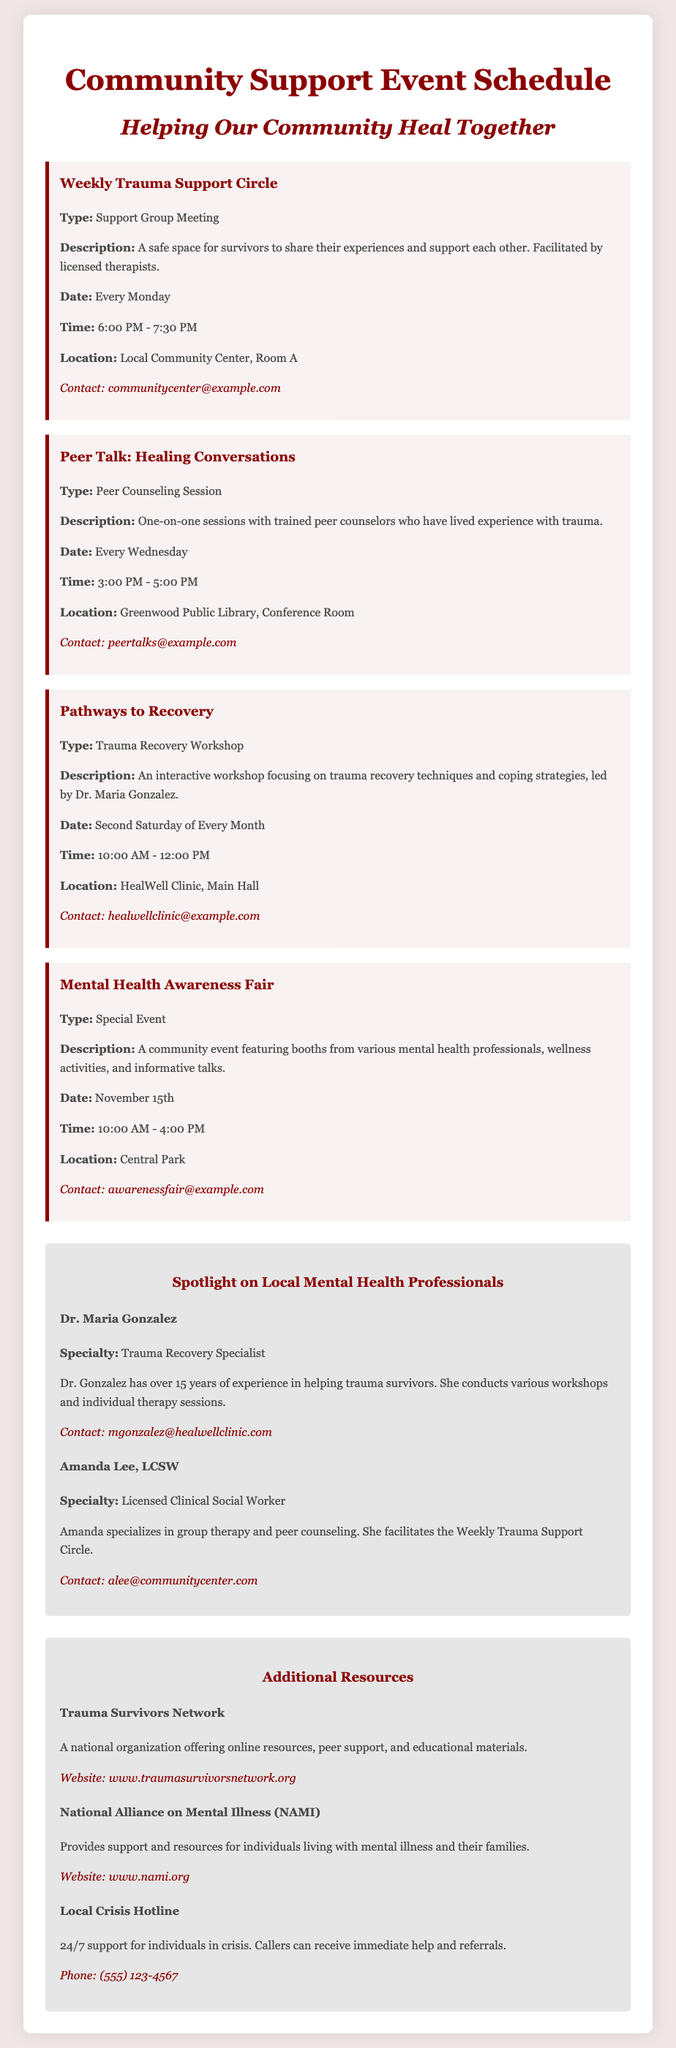What is the location of the Weekly Trauma Support Circle? The location for the Weekly Trauma Support Circle is specified as the Local Community Center, Room A.
Answer: Local Community Center, Room A What day and time does the Pathways to Recovery workshop occur? The Pathways to Recovery workshop takes place on the second Saturday of every month from 10:00 AM to 12:00 PM.
Answer: Second Saturday of Every Month, 10:00 AM - 12:00 PM Who facilitates the Peer Talk: Healing Conversations sessions? The Peer Talk: Healing Conversations sessions are conducted by trained peer counselors who have lived experience with trauma.
Answer: Trained peer counselors What type of event is the Mental Health Awareness Fair? The Mental Health Awareness Fair is classified as a special event according to the document's description.
Answer: Special Event Who is the trauma recovery specialist spotlighted in the document? The document highlights Dr. Maria Gonzalez as the trauma recovery specialist.
Answer: Dr. Maria Gonzalez How often does the Weekly Trauma Support Circle meet? The Weekly Trauma Support Circle meets weekly, specifically every Monday.
Answer: Every Monday What is the contact email for the Peer Talk: Healing Conversations? The contact email provided for Peer Talk: Healing Conversations is peertalks@example.com.
Answer: peertalks@example.com What type of resources does the Trauma Survivors Network offer? The Trauma Survivors Network offers online resources, peer support, and educational materials.
Answer: Online resources, peer support, educational materials What is the phone number for the Local Crisis Hotline? The phone number listed for the Local Crisis Hotline is (555) 123-4567.
Answer: (555) 123-4567 